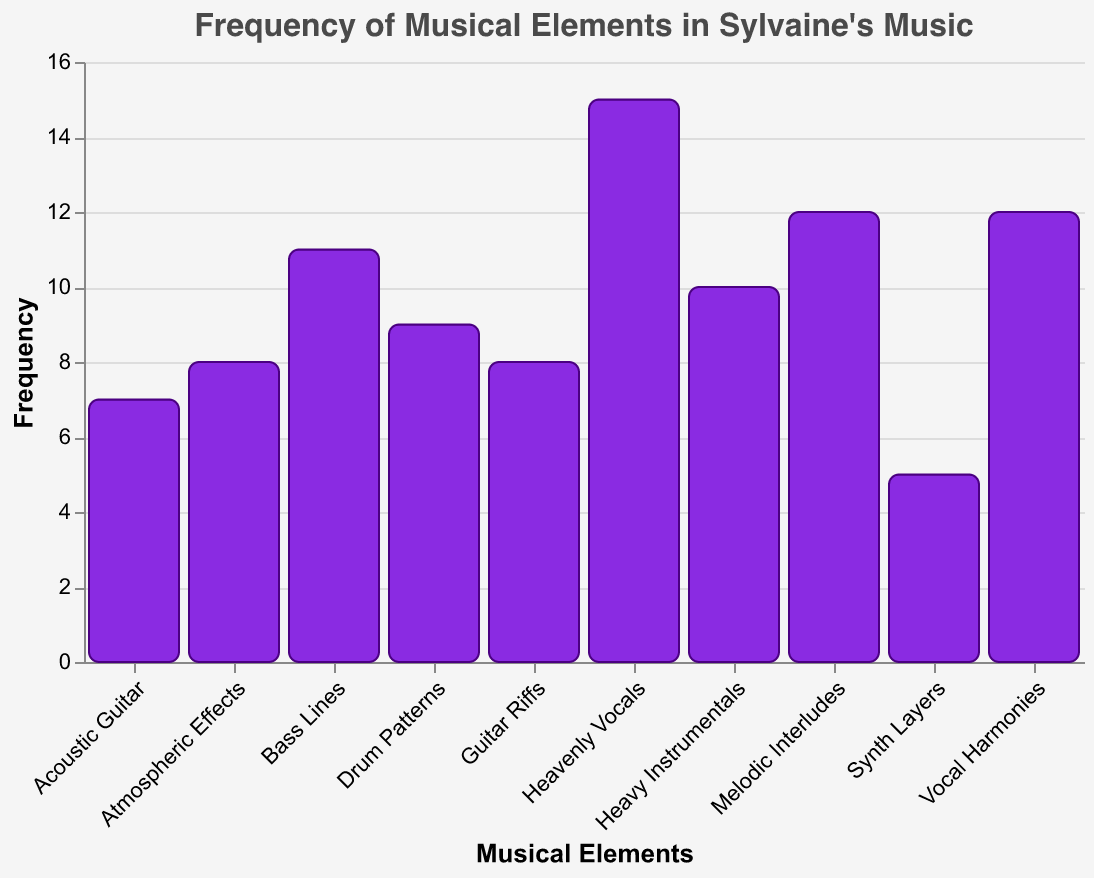What is the title of the figure? The title can be found at the top of the plot. It reads "Frequency of Musical Elements in Sylvaine's Music".
Answer: Frequency of Musical Elements in Sylvaine's Music Which musical element has the highest frequency? By observing the y-axis values, "Heavenly Vocals" has the highest frequency with 15.
Answer: Heavenly Vocals How many musical elements have a frequency greater than or equal to 12? From the plot, the elements with frequencies greater than or equal to 12 are "Vocal Harmonies," "Heavenly Vocals," and "Melodic Interludes". There are 3 such elements.
Answer: 3 What is the frequency of the least common musical element? The plot shows that "Synth Layers" has the lowest frequency with 5.
Answer: 5 What is the difference in frequency between "Vocal Harmonies" and "Guitar Riffs"? The frequency of "Vocal Harmonies" is 12, and the frequency of "Guitar Riffs" is 8. The difference is 12 - 8 = 4.
Answer: 4 What is the total frequency of all musical elements combined? Summing up all the frequencies: 12 + 8 + 15 + 10 + 7 + 5 + 9 + 11 + 8 + 12 = 97.
Answer: 97 Which musical elements have a frequency of exactly 8? From the plot, the elements with a frequency of 8 are "Guitar Riffs" and "Atmospheric Effects".
Answer: Guitar Riffs, Atmospheric Effects Which musical element is more frequent: "Heavy Instrumentals" or "Bass Lines"? The frequency of "Heavy Instrumentals" is 10, while the frequency of "Bass Lines" is 11. Thus, "Bass Lines" is more frequent.
Answer: Bass Lines 